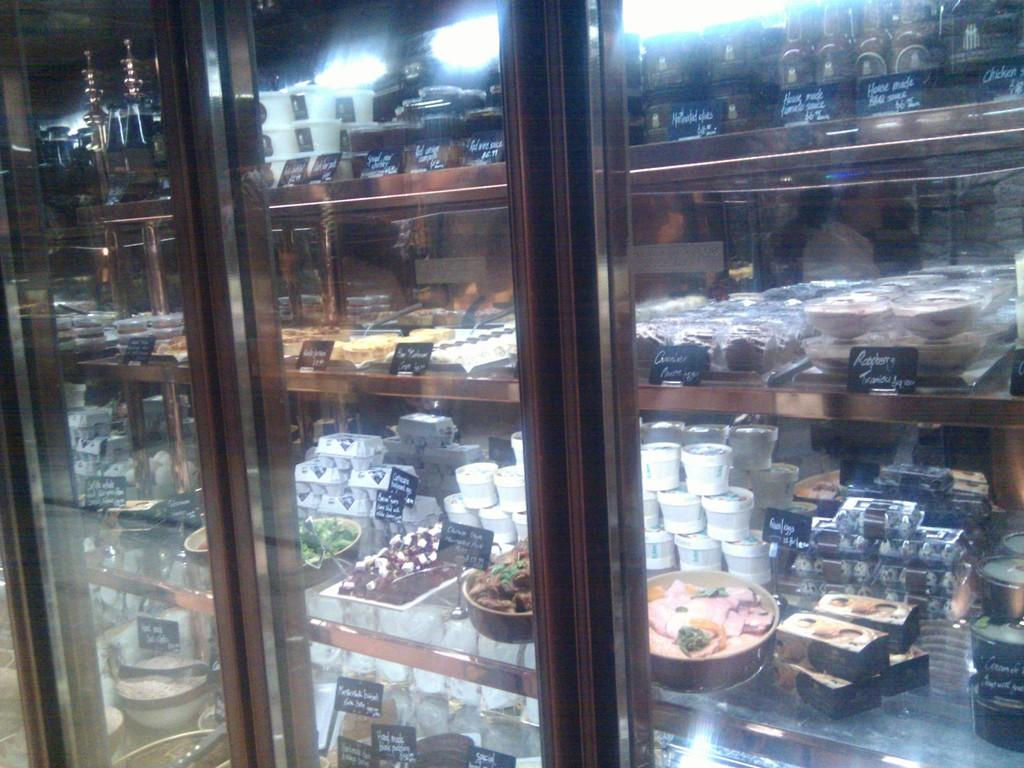What object is present in the image that can hold liquids? There is a glass in the image. What can be seen inside the glass? Food items are visible through the glass. What type of signage is present in the image? Price rate boards are present in the image. Where is the harbor located in the image? There is no harbor present in the image. What type of cover is used to protect the food items in the image? The image does not show any covers being used to protect the food items. 